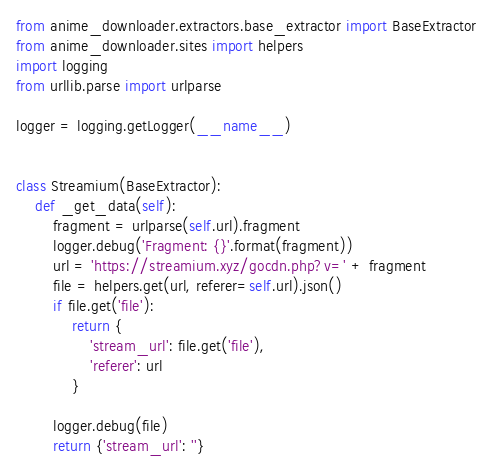<code> <loc_0><loc_0><loc_500><loc_500><_Python_>from anime_downloader.extractors.base_extractor import BaseExtractor
from anime_downloader.sites import helpers
import logging
from urllib.parse import urlparse

logger = logging.getLogger(__name__)


class Streamium(BaseExtractor):
    def _get_data(self):
        fragment = urlparse(self.url).fragment
        logger.debug('Fragment: {}'.format(fragment))
        url = 'https://streamium.xyz/gocdn.php?v=' + fragment
        file = helpers.get(url, referer=self.url).json()
        if file.get('file'):
            return {
                'stream_url': file.get('file'),
                'referer': url
            }

        logger.debug(file)
        return {'stream_url': ''}
</code> 